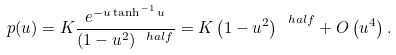Convert formula to latex. <formula><loc_0><loc_0><loc_500><loc_500>p ( u ) = K \frac { e ^ { - u \tanh ^ { - 1 } u } } { ( 1 - u ^ { 2 } ) ^ { \ h a l f } } = K \left ( 1 - u ^ { 2 } \right ) ^ { \ h a l f } + O \left ( u ^ { 4 } \right ) .</formula> 